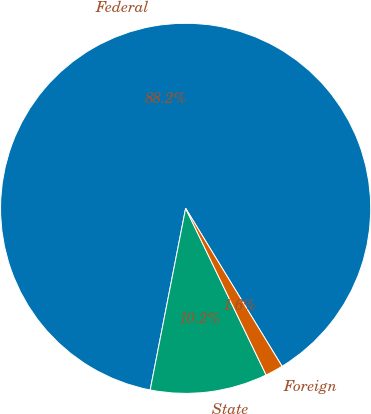Convert chart to OTSL. <chart><loc_0><loc_0><loc_500><loc_500><pie_chart><fcel>Federal<fcel>State<fcel>Foreign<nl><fcel>88.21%<fcel>10.23%<fcel>1.56%<nl></chart> 